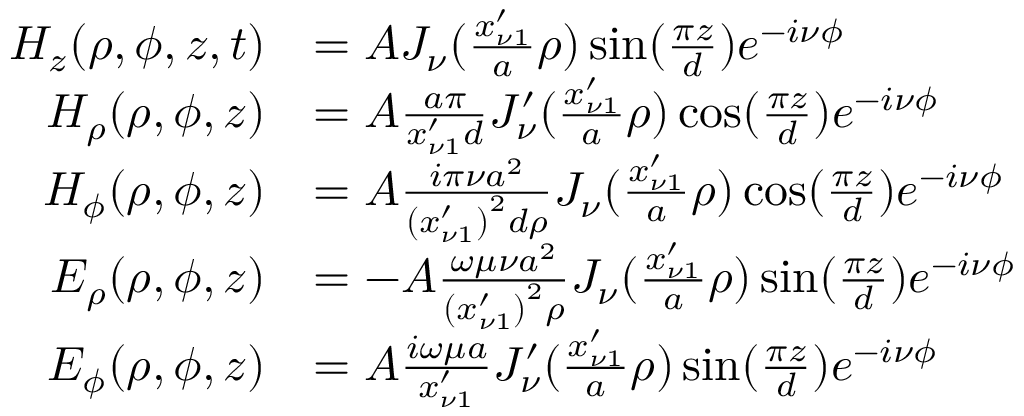Convert formula to latex. <formula><loc_0><loc_0><loc_500><loc_500>\begin{array} { r l } { H _ { z } ( \rho , \phi , z , t ) } & { = A J _ { \nu } ( \frac { x _ { \nu 1 } ^ { \prime } } { a } \rho ) \sin ( \frac { \pi z } { d } ) e ^ { - i \nu \phi } } \\ { H _ { \rho } ( \rho , \phi , z ) } & { = A \frac { a \pi } { x _ { \nu 1 } ^ { \prime } d } J _ { \nu } ^ { \prime } ( \frac { x _ { \nu 1 } ^ { \prime } } { a } \rho ) \cos ( \frac { \pi z } { d } ) e ^ { - i \nu \phi } } \\ { H _ { \phi } ( \rho , \phi , z ) } & { = A \frac { i \pi \nu a ^ { 2 } } { \left ( x _ { \nu 1 } ^ { \prime } \right ) ^ { 2 } d \rho } J _ { \nu } ( \frac { x _ { \nu 1 } ^ { \prime } } { a } \rho ) \cos ( \frac { \pi z } { d } ) e ^ { - i \nu \phi } } \\ { E _ { \rho } ( \rho , \phi , z ) } & { = - A \frac { \omega \mu \nu a ^ { 2 } } { \left ( x _ { \nu 1 } ^ { \prime } \right ) ^ { 2 } \rho } J _ { \nu } ( \frac { x _ { \nu 1 } ^ { \prime } } { a } \rho ) \sin ( \frac { \pi z } { d } ) e ^ { - i \nu \phi } } \\ { E _ { \phi } ( \rho , \phi , z ) } & { = A \frac { i \omega \mu a } { x _ { \nu 1 } ^ { \prime } } J _ { \nu } ^ { \prime } ( \frac { x _ { \nu 1 } ^ { \prime } } { a } \rho ) \sin ( \frac { \pi z } { d } ) e ^ { - i \nu \phi } } \end{array}</formula> 